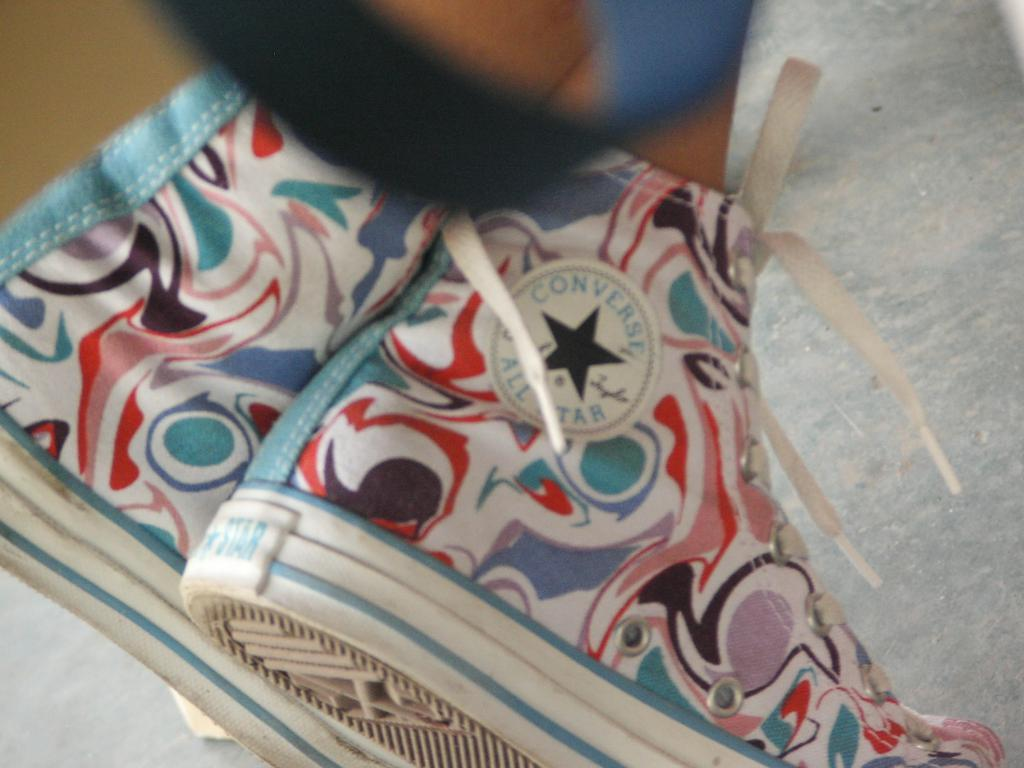What body part of a person can be seen in the image? There is a person's legs visible in the image. What type of footwear is the person wearing? The person is wearing shoes. Can you describe any specific features of the shoes? There is a logo on the shoe. What type of letter is the tiger holding in the image? There is no tiger or letter present in the image. Is there a patch on the person's clothing in the image? The provided facts do not mention any patches on the person's clothing, so we cannot determine if there is a patch present. 